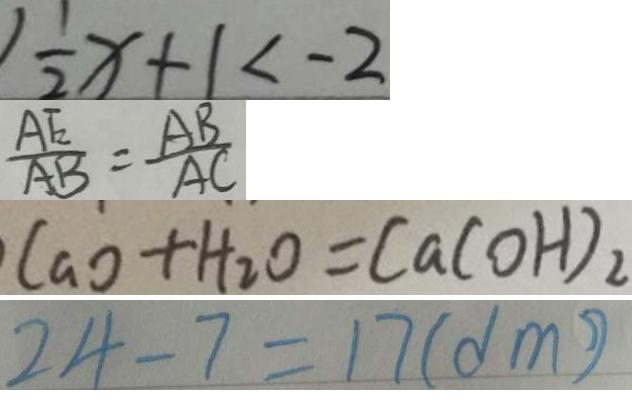Convert formula to latex. <formula><loc_0><loc_0><loc_500><loc_500>\frac { 1 } { 2 } x + 1 < - 2 
 \frac { A E } { A B } = \frac { A B } { A C } 
 C a O + H _ { 2 } O = C a ( O H ) _ { 2 } 
 2 4 - 7 = 1 7 ( d m )</formula> 